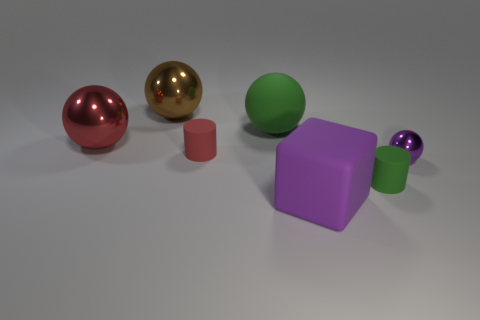There is a small object that is the same color as the big block; what material is it?
Ensure brevity in your answer.  Metal. How many things are the same color as the tiny metallic sphere?
Ensure brevity in your answer.  1. Are there any green rubber cylinders that have the same size as the matte cube?
Give a very brief answer. No. What is the shape of the purple rubber thing that is the same size as the red sphere?
Your answer should be compact. Cube. Are there any large red shiny objects of the same shape as the small metallic thing?
Your answer should be compact. Yes. Is the large red ball made of the same material as the large sphere to the right of the large brown shiny ball?
Provide a succinct answer. No. Are there any small metal objects of the same color as the rubber cube?
Your response must be concise. Yes. What number of other things are made of the same material as the large block?
Provide a short and direct response. 3. Does the large rubber block have the same color as the large shiny ball that is in front of the large brown sphere?
Make the answer very short. No. Is the number of big brown shiny things to the left of the green rubber ball greater than the number of small brown objects?
Offer a very short reply. Yes. 